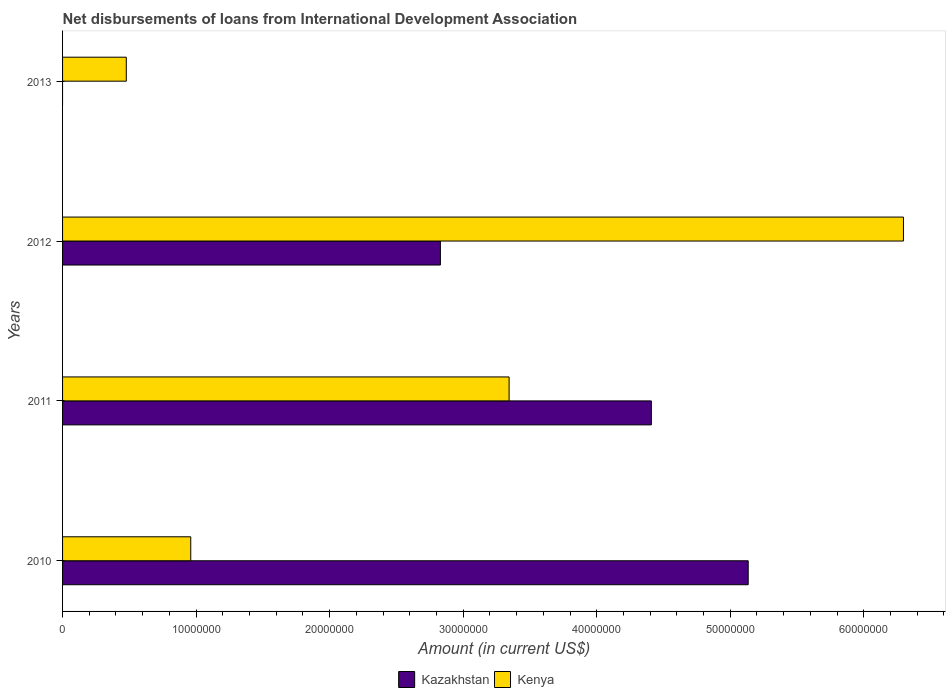How many different coloured bars are there?
Offer a terse response. 2. Are the number of bars on each tick of the Y-axis equal?
Make the answer very short. No. How many bars are there on the 3rd tick from the bottom?
Keep it short and to the point. 2. What is the amount of loans disbursed in Kazakhstan in 2010?
Your response must be concise. 5.13e+07. Across all years, what is the maximum amount of loans disbursed in Kazakhstan?
Provide a succinct answer. 5.13e+07. What is the total amount of loans disbursed in Kazakhstan in the graph?
Your answer should be compact. 1.24e+08. What is the difference between the amount of loans disbursed in Kenya in 2010 and that in 2012?
Provide a succinct answer. -5.34e+07. What is the difference between the amount of loans disbursed in Kenya in 2011 and the amount of loans disbursed in Kazakhstan in 2012?
Your answer should be very brief. 5.14e+06. What is the average amount of loans disbursed in Kazakhstan per year?
Your response must be concise. 3.09e+07. In the year 2010, what is the difference between the amount of loans disbursed in Kenya and amount of loans disbursed in Kazakhstan?
Give a very brief answer. -4.17e+07. In how many years, is the amount of loans disbursed in Kenya greater than 10000000 US$?
Your answer should be compact. 2. What is the ratio of the amount of loans disbursed in Kenya in 2011 to that in 2013?
Ensure brevity in your answer.  7.01. Is the difference between the amount of loans disbursed in Kenya in 2011 and 2012 greater than the difference between the amount of loans disbursed in Kazakhstan in 2011 and 2012?
Your answer should be compact. No. What is the difference between the highest and the second highest amount of loans disbursed in Kazakhstan?
Offer a terse response. 7.25e+06. What is the difference between the highest and the lowest amount of loans disbursed in Kazakhstan?
Your response must be concise. 5.13e+07. In how many years, is the amount of loans disbursed in Kazakhstan greater than the average amount of loans disbursed in Kazakhstan taken over all years?
Your answer should be compact. 2. Are all the bars in the graph horizontal?
Your answer should be very brief. Yes. How many years are there in the graph?
Provide a succinct answer. 4. Are the values on the major ticks of X-axis written in scientific E-notation?
Your answer should be very brief. No. Does the graph contain any zero values?
Offer a terse response. Yes. How many legend labels are there?
Keep it short and to the point. 2. How are the legend labels stacked?
Provide a short and direct response. Horizontal. What is the title of the graph?
Offer a terse response. Net disbursements of loans from International Development Association. What is the label or title of the X-axis?
Your answer should be compact. Amount (in current US$). What is the Amount (in current US$) of Kazakhstan in 2010?
Keep it short and to the point. 5.13e+07. What is the Amount (in current US$) of Kenya in 2010?
Provide a short and direct response. 9.60e+06. What is the Amount (in current US$) of Kazakhstan in 2011?
Offer a terse response. 4.41e+07. What is the Amount (in current US$) in Kenya in 2011?
Provide a succinct answer. 3.34e+07. What is the Amount (in current US$) in Kazakhstan in 2012?
Your answer should be compact. 2.83e+07. What is the Amount (in current US$) of Kenya in 2012?
Keep it short and to the point. 6.30e+07. What is the Amount (in current US$) in Kenya in 2013?
Give a very brief answer. 4.77e+06. Across all years, what is the maximum Amount (in current US$) of Kazakhstan?
Keep it short and to the point. 5.13e+07. Across all years, what is the maximum Amount (in current US$) in Kenya?
Your answer should be compact. 6.30e+07. Across all years, what is the minimum Amount (in current US$) in Kenya?
Offer a terse response. 4.77e+06. What is the total Amount (in current US$) in Kazakhstan in the graph?
Offer a very short reply. 1.24e+08. What is the total Amount (in current US$) in Kenya in the graph?
Provide a short and direct response. 1.11e+08. What is the difference between the Amount (in current US$) of Kazakhstan in 2010 and that in 2011?
Your response must be concise. 7.25e+06. What is the difference between the Amount (in current US$) in Kenya in 2010 and that in 2011?
Your answer should be compact. -2.38e+07. What is the difference between the Amount (in current US$) of Kazakhstan in 2010 and that in 2012?
Ensure brevity in your answer.  2.30e+07. What is the difference between the Amount (in current US$) in Kenya in 2010 and that in 2012?
Provide a short and direct response. -5.34e+07. What is the difference between the Amount (in current US$) in Kenya in 2010 and that in 2013?
Provide a short and direct response. 4.83e+06. What is the difference between the Amount (in current US$) in Kazakhstan in 2011 and that in 2012?
Provide a succinct answer. 1.58e+07. What is the difference between the Amount (in current US$) of Kenya in 2011 and that in 2012?
Offer a very short reply. -2.95e+07. What is the difference between the Amount (in current US$) in Kenya in 2011 and that in 2013?
Your answer should be compact. 2.87e+07. What is the difference between the Amount (in current US$) of Kenya in 2012 and that in 2013?
Keep it short and to the point. 5.82e+07. What is the difference between the Amount (in current US$) in Kazakhstan in 2010 and the Amount (in current US$) in Kenya in 2011?
Provide a succinct answer. 1.79e+07. What is the difference between the Amount (in current US$) of Kazakhstan in 2010 and the Amount (in current US$) of Kenya in 2012?
Keep it short and to the point. -1.16e+07. What is the difference between the Amount (in current US$) in Kazakhstan in 2010 and the Amount (in current US$) in Kenya in 2013?
Make the answer very short. 4.66e+07. What is the difference between the Amount (in current US$) in Kazakhstan in 2011 and the Amount (in current US$) in Kenya in 2012?
Offer a very short reply. -1.89e+07. What is the difference between the Amount (in current US$) of Kazakhstan in 2011 and the Amount (in current US$) of Kenya in 2013?
Make the answer very short. 3.93e+07. What is the difference between the Amount (in current US$) in Kazakhstan in 2012 and the Amount (in current US$) in Kenya in 2013?
Offer a terse response. 2.35e+07. What is the average Amount (in current US$) of Kazakhstan per year?
Keep it short and to the point. 3.09e+07. What is the average Amount (in current US$) in Kenya per year?
Give a very brief answer. 2.77e+07. In the year 2010, what is the difference between the Amount (in current US$) of Kazakhstan and Amount (in current US$) of Kenya?
Your response must be concise. 4.17e+07. In the year 2011, what is the difference between the Amount (in current US$) of Kazakhstan and Amount (in current US$) of Kenya?
Keep it short and to the point. 1.07e+07. In the year 2012, what is the difference between the Amount (in current US$) in Kazakhstan and Amount (in current US$) in Kenya?
Your answer should be compact. -3.47e+07. What is the ratio of the Amount (in current US$) of Kazakhstan in 2010 to that in 2011?
Make the answer very short. 1.16. What is the ratio of the Amount (in current US$) of Kenya in 2010 to that in 2011?
Provide a succinct answer. 0.29. What is the ratio of the Amount (in current US$) in Kazakhstan in 2010 to that in 2012?
Keep it short and to the point. 1.81. What is the ratio of the Amount (in current US$) of Kenya in 2010 to that in 2012?
Your answer should be very brief. 0.15. What is the ratio of the Amount (in current US$) in Kenya in 2010 to that in 2013?
Your answer should be compact. 2.01. What is the ratio of the Amount (in current US$) of Kazakhstan in 2011 to that in 2012?
Your response must be concise. 1.56. What is the ratio of the Amount (in current US$) in Kenya in 2011 to that in 2012?
Ensure brevity in your answer.  0.53. What is the ratio of the Amount (in current US$) of Kenya in 2011 to that in 2013?
Offer a terse response. 7.01. What is the ratio of the Amount (in current US$) of Kenya in 2012 to that in 2013?
Provide a short and direct response. 13.2. What is the difference between the highest and the second highest Amount (in current US$) of Kazakhstan?
Offer a very short reply. 7.25e+06. What is the difference between the highest and the second highest Amount (in current US$) of Kenya?
Offer a terse response. 2.95e+07. What is the difference between the highest and the lowest Amount (in current US$) of Kazakhstan?
Give a very brief answer. 5.13e+07. What is the difference between the highest and the lowest Amount (in current US$) of Kenya?
Offer a terse response. 5.82e+07. 